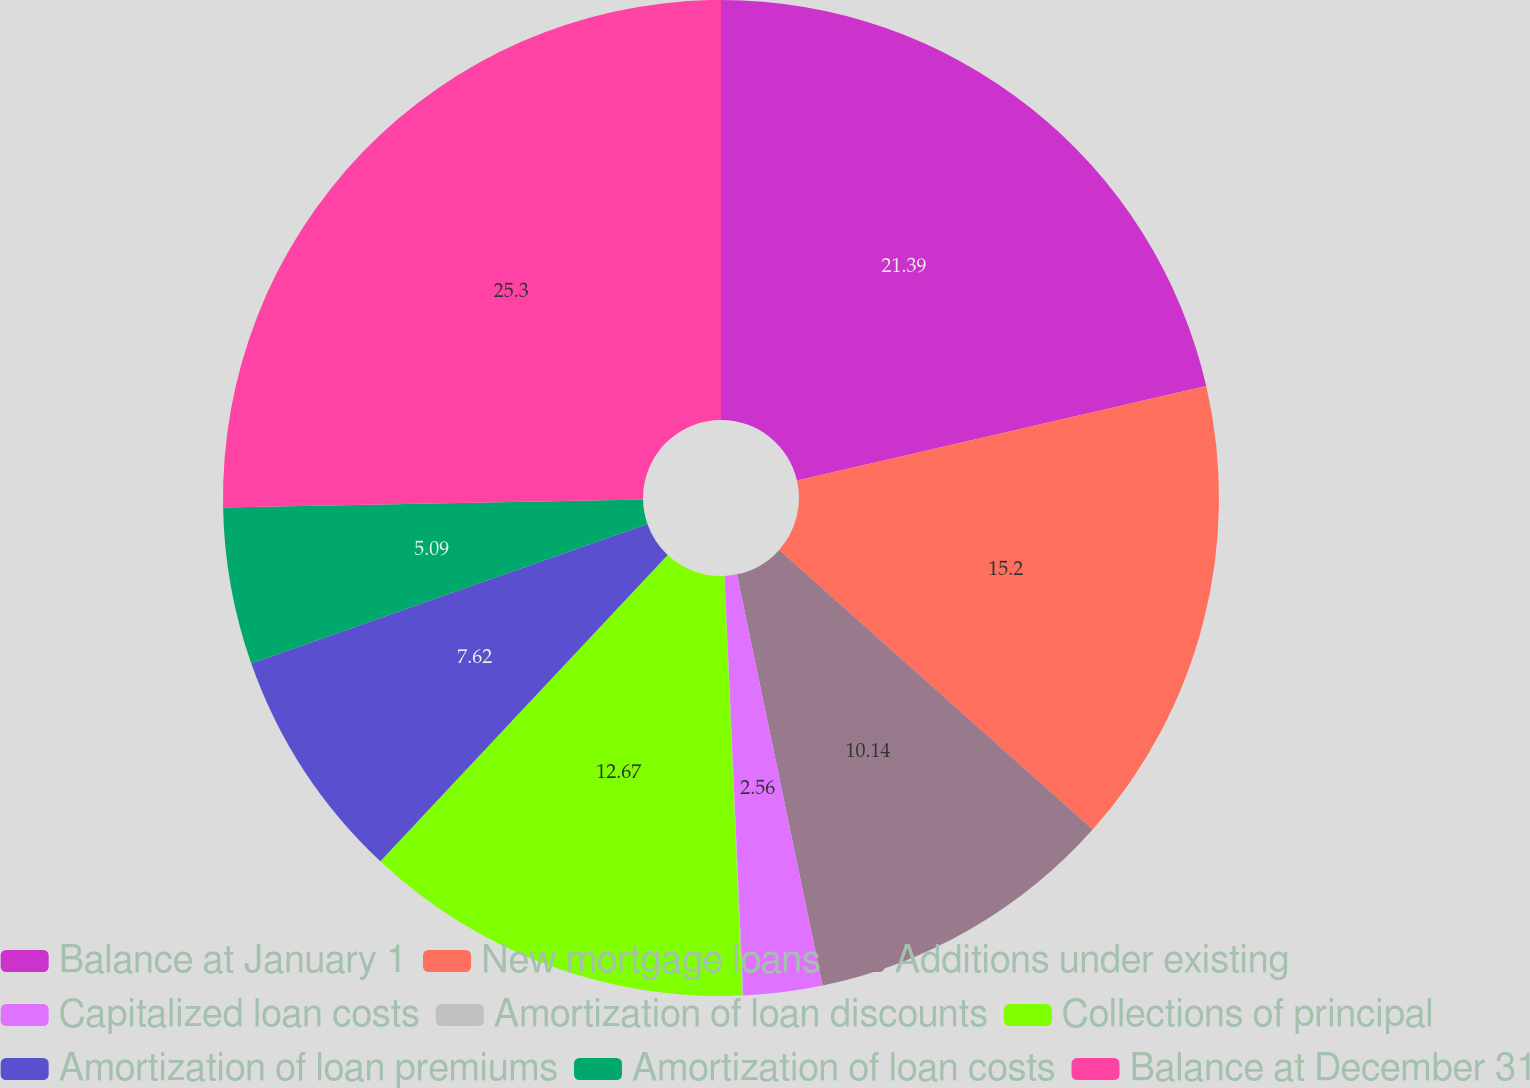Convert chart. <chart><loc_0><loc_0><loc_500><loc_500><pie_chart><fcel>Balance at January 1<fcel>New mortgage loans<fcel>Additions under existing<fcel>Capitalized loan costs<fcel>Amortization of loan discounts<fcel>Collections of principal<fcel>Amortization of loan premiums<fcel>Amortization of loan costs<fcel>Balance at December 31<nl><fcel>21.39%<fcel>15.2%<fcel>10.14%<fcel>2.56%<fcel>0.03%<fcel>12.67%<fcel>7.62%<fcel>5.09%<fcel>25.3%<nl></chart> 